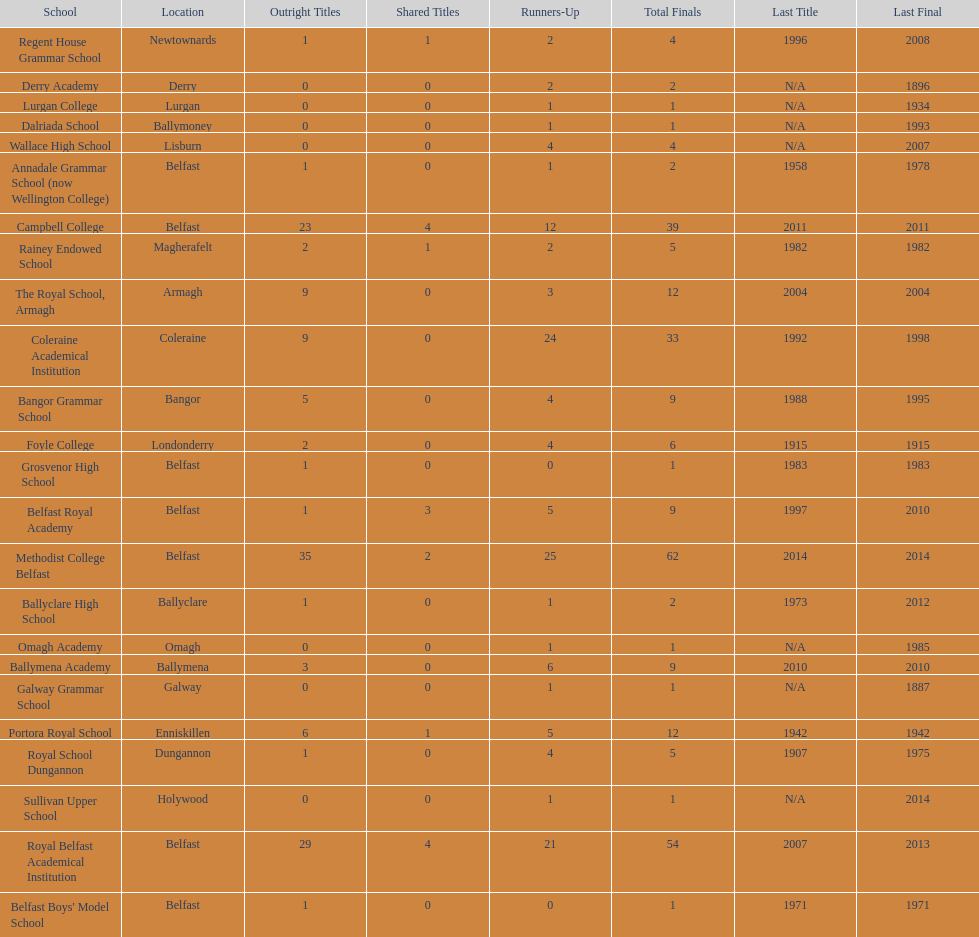Could you parse the entire table? {'header': ['School', 'Location', 'Outright Titles', 'Shared Titles', 'Runners-Up', 'Total Finals', 'Last Title', 'Last Final'], 'rows': [['Regent House Grammar School', 'Newtownards', '1', '1', '2', '4', '1996', '2008'], ['Derry Academy', 'Derry', '0', '0', '2', '2', 'N/A', '1896'], ['Lurgan College', 'Lurgan', '0', '0', '1', '1', 'N/A', '1934'], ['Dalriada School', 'Ballymoney', '0', '0', '1', '1', 'N/A', '1993'], ['Wallace High School', 'Lisburn', '0', '0', '4', '4', 'N/A', '2007'], ['Annadale Grammar School (now Wellington College)', 'Belfast', '1', '0', '1', '2', '1958', '1978'], ['Campbell College', 'Belfast', '23', '4', '12', '39', '2011', '2011'], ['Rainey Endowed School', 'Magherafelt', '2', '1', '2', '5', '1982', '1982'], ['The Royal School, Armagh', 'Armagh', '9', '0', '3', '12', '2004', '2004'], ['Coleraine Academical Institution', 'Coleraine', '9', '0', '24', '33', '1992', '1998'], ['Bangor Grammar School', 'Bangor', '5', '0', '4', '9', '1988', '1995'], ['Foyle College', 'Londonderry', '2', '0', '4', '6', '1915', '1915'], ['Grosvenor High School', 'Belfast', '1', '0', '0', '1', '1983', '1983'], ['Belfast Royal Academy', 'Belfast', '1', '3', '5', '9', '1997', '2010'], ['Methodist College Belfast', 'Belfast', '35', '2', '25', '62', '2014', '2014'], ['Ballyclare High School', 'Ballyclare', '1', '0', '1', '2', '1973', '2012'], ['Omagh Academy', 'Omagh', '0', '0', '1', '1', 'N/A', '1985'], ['Ballymena Academy', 'Ballymena', '3', '0', '6', '9', '2010', '2010'], ['Galway Grammar School', 'Galway', '0', '0', '1', '1', 'N/A', '1887'], ['Portora Royal School', 'Enniskillen', '6', '1', '5', '12', '1942', '1942'], ['Royal School Dungannon', 'Dungannon', '1', '0', '4', '5', '1907', '1975'], ['Sullivan Upper School', 'Holywood', '0', '0', '1', '1', 'N/A', '2014'], ['Royal Belfast Academical Institution', 'Belfast', '29', '4', '21', '54', '2007', '2013'], ["Belfast Boys' Model School", 'Belfast', '1', '0', '0', '1', '1971', '1971']]} Did belfast royal academy have more or less total finals than ballyclare high school? More. 